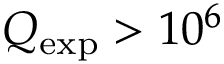<formula> <loc_0><loc_0><loc_500><loc_500>Q _ { e x p } > 1 0 ^ { 6 }</formula> 